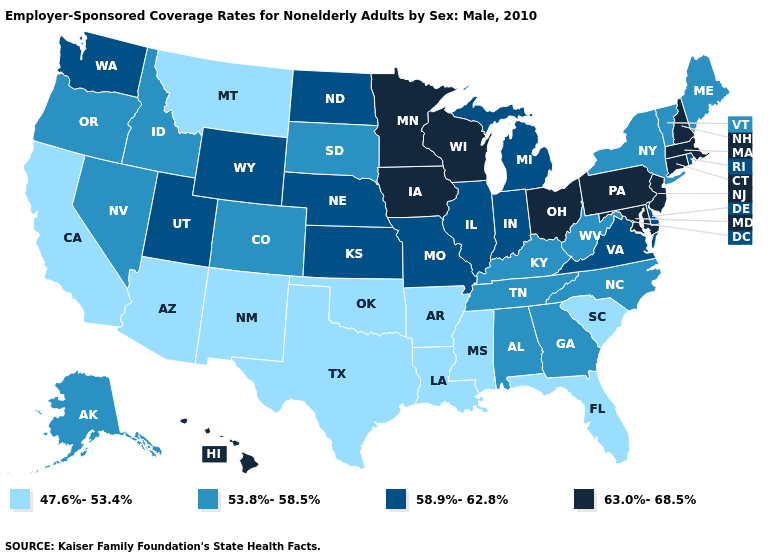Which states have the lowest value in the USA?
Answer briefly. Arizona, Arkansas, California, Florida, Louisiana, Mississippi, Montana, New Mexico, Oklahoma, South Carolina, Texas. What is the highest value in states that border South Carolina?
Short answer required. 53.8%-58.5%. What is the value of Ohio?
Quick response, please. 63.0%-68.5%. Does Virginia have a lower value than Michigan?
Quick response, please. No. Does Minnesota have a higher value than New Hampshire?
Keep it brief. No. What is the value of West Virginia?
Quick response, please. 53.8%-58.5%. What is the highest value in the USA?
Write a very short answer. 63.0%-68.5%. What is the value of Kentucky?
Be succinct. 53.8%-58.5%. What is the lowest value in states that border Tennessee?
Be succinct. 47.6%-53.4%. What is the lowest value in states that border New Hampshire?
Be succinct. 53.8%-58.5%. Name the states that have a value in the range 58.9%-62.8%?
Short answer required. Delaware, Illinois, Indiana, Kansas, Michigan, Missouri, Nebraska, North Dakota, Rhode Island, Utah, Virginia, Washington, Wyoming. Does Maine have the highest value in the USA?
Write a very short answer. No. Does Arkansas have the lowest value in the South?
Answer briefly. Yes. What is the value of Alabama?
Write a very short answer. 53.8%-58.5%. Is the legend a continuous bar?
Keep it brief. No. 